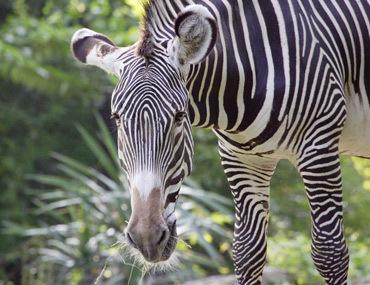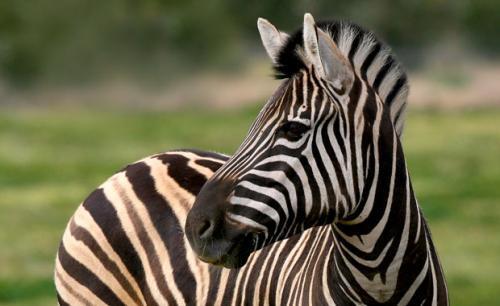The first image is the image on the left, the second image is the image on the right. For the images shown, is this caption "Each image contains one zebra standing with head and body in profile, but the zebra on the right has its head bent lower." true? Answer yes or no. No. The first image is the image on the left, the second image is the image on the right. For the images displayed, is the sentence "One zebra is facing right." factually correct? Answer yes or no. No. 